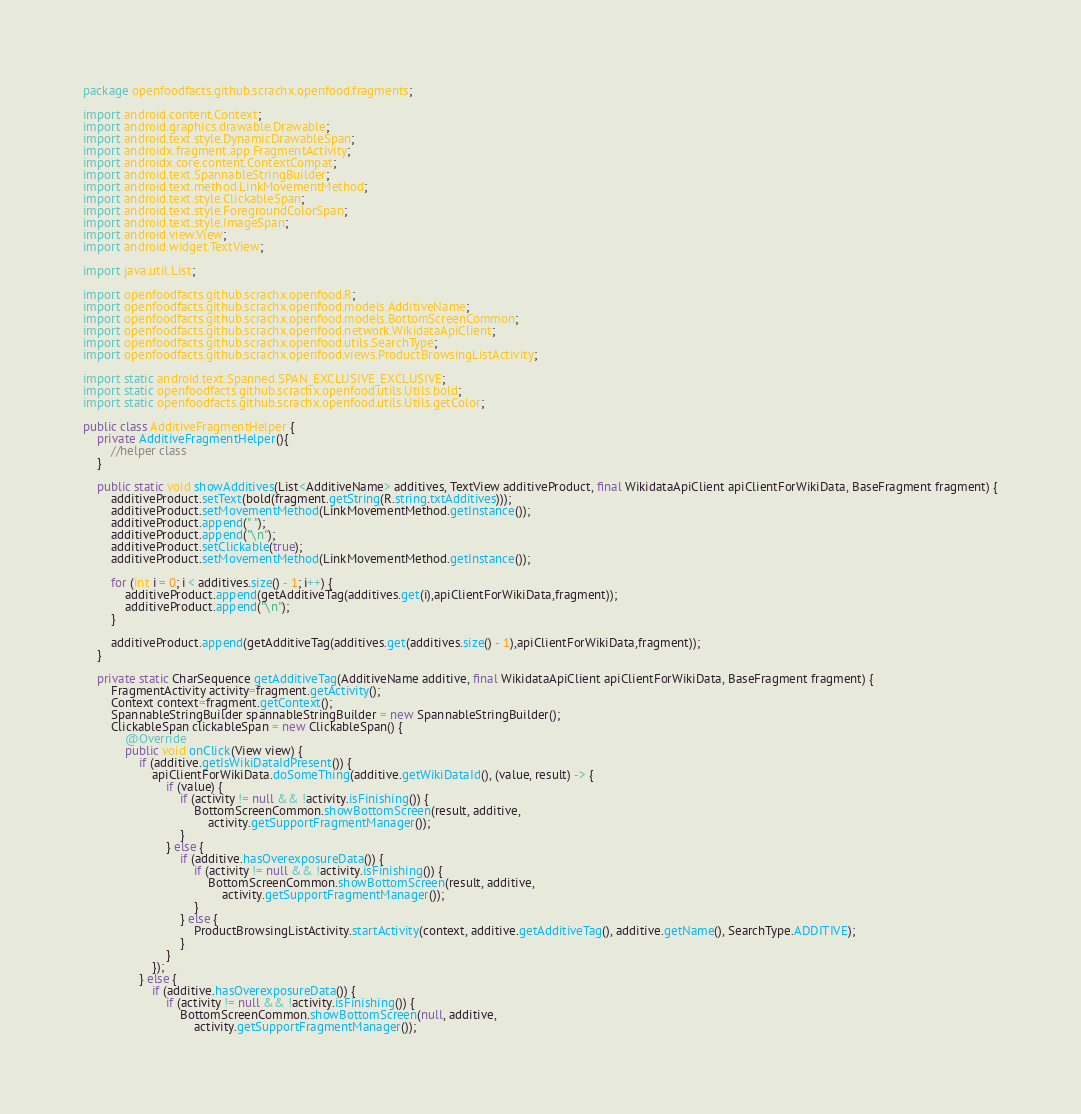<code> <loc_0><loc_0><loc_500><loc_500><_Java_>package openfoodfacts.github.scrachx.openfood.fragments;

import android.content.Context;
import android.graphics.drawable.Drawable;
import android.text.style.DynamicDrawableSpan;
import androidx.fragment.app.FragmentActivity;
import androidx.core.content.ContextCompat;
import android.text.SpannableStringBuilder;
import android.text.method.LinkMovementMethod;
import android.text.style.ClickableSpan;
import android.text.style.ForegroundColorSpan;
import android.text.style.ImageSpan;
import android.view.View;
import android.widget.TextView;

import java.util.List;

import openfoodfacts.github.scrachx.openfood.R;
import openfoodfacts.github.scrachx.openfood.models.AdditiveName;
import openfoodfacts.github.scrachx.openfood.models.BottomScreenCommon;
import openfoodfacts.github.scrachx.openfood.network.WikidataApiClient;
import openfoodfacts.github.scrachx.openfood.utils.SearchType;
import openfoodfacts.github.scrachx.openfood.views.ProductBrowsingListActivity;

import static android.text.Spanned.SPAN_EXCLUSIVE_EXCLUSIVE;
import static openfoodfacts.github.scrachx.openfood.utils.Utils.bold;
import static openfoodfacts.github.scrachx.openfood.utils.Utils.getColor;

public class AdditiveFragmentHelper {
    private AdditiveFragmentHelper(){
        //helper class
    }

    public static void showAdditives(List<AdditiveName> additives, TextView additiveProduct, final WikidataApiClient apiClientForWikiData, BaseFragment fragment) {
        additiveProduct.setText(bold(fragment.getString(R.string.txtAdditives)));
        additiveProduct.setMovementMethod(LinkMovementMethod.getInstance());
        additiveProduct.append(" ");
        additiveProduct.append("\n");
        additiveProduct.setClickable(true);
        additiveProduct.setMovementMethod(LinkMovementMethod.getInstance());

        for (int i = 0; i < additives.size() - 1; i++) {
            additiveProduct.append(getAdditiveTag(additives.get(i),apiClientForWikiData,fragment));
            additiveProduct.append("\n");
        }

        additiveProduct.append(getAdditiveTag(additives.get(additives.size() - 1),apiClientForWikiData,fragment));
    }

    private static CharSequence getAdditiveTag(AdditiveName additive, final WikidataApiClient apiClientForWikiData, BaseFragment fragment) {
        FragmentActivity activity=fragment.getActivity();
        Context context=fragment.getContext();
        SpannableStringBuilder spannableStringBuilder = new SpannableStringBuilder();
        ClickableSpan clickableSpan = new ClickableSpan() {
            @Override
            public void onClick(View view) {
                if (additive.getIsWikiDataIdPresent()) {
                    apiClientForWikiData.doSomeThing(additive.getWikiDataId(), (value, result) -> {
                        if (value) {
                            if (activity != null && !activity.isFinishing()) {
                                BottomScreenCommon.showBottomScreen(result, additive,
                                    activity.getSupportFragmentManager());
                            }
                        } else {
                            if (additive.hasOverexposureData()) {
                                if (activity != null && !activity.isFinishing()) {
                                    BottomScreenCommon.showBottomScreen(result, additive,
                                        activity.getSupportFragmentManager());
                                }
                            } else {
                                ProductBrowsingListActivity.startActivity(context, additive.getAdditiveTag(), additive.getName(), SearchType.ADDITIVE);
                            }
                        }
                    });
                } else {
                    if (additive.hasOverexposureData()) {
                        if (activity != null && !activity.isFinishing()) {
                            BottomScreenCommon.showBottomScreen(null, additive,
                                activity.getSupportFragmentManager());</code> 